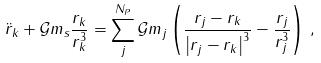<formula> <loc_0><loc_0><loc_500><loc_500>\ddot { r } _ { k } + \mathcal { G } m _ { s } \frac { r _ { k } } { r _ { k } ^ { 3 } } = \sum _ { j } ^ { N _ { P } } \mathcal { G } m _ { j } \left ( \frac { r _ { j } - r _ { k } } { \left | r _ { j } - r _ { k } \right | ^ { 3 } } - \frac { r _ { j } } { r _ { j } ^ { 3 } } \right ) \, ,</formula> 